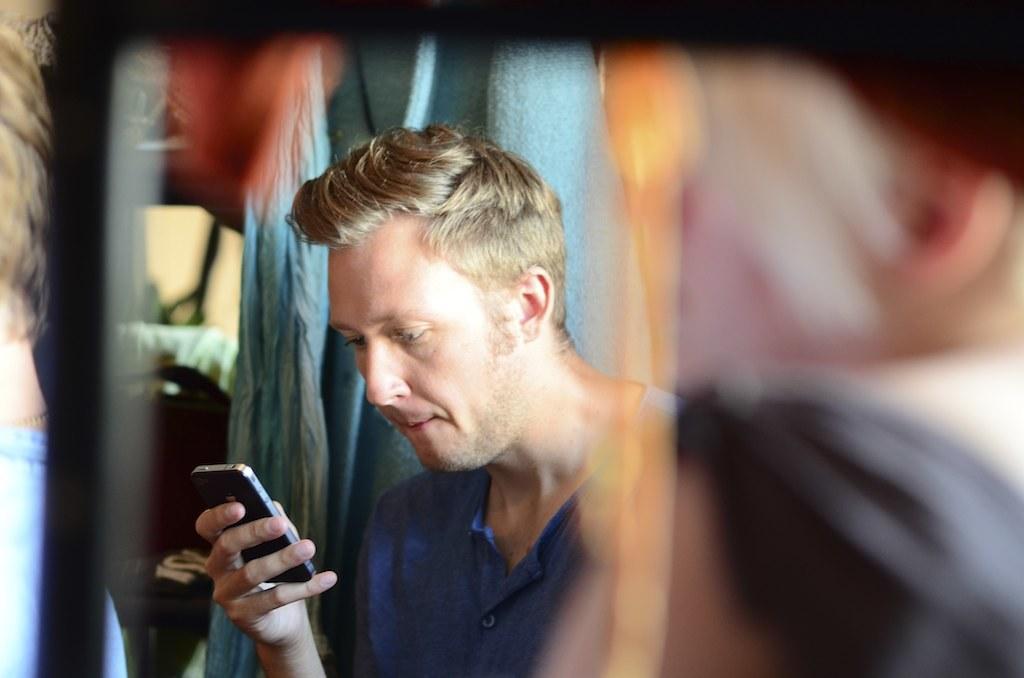Could you give a brief overview of what you see in this image? In this picture we can see a man in blue dress holding a phone 